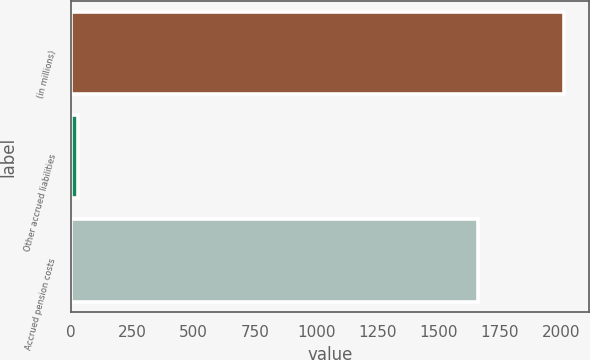Convert chart to OTSL. <chart><loc_0><loc_0><loc_500><loc_500><bar_chart><fcel>(in millions)<fcel>Other accrued liabilities<fcel>Accrued pension costs<nl><fcel>2011<fcel>28<fcel>1662<nl></chart> 